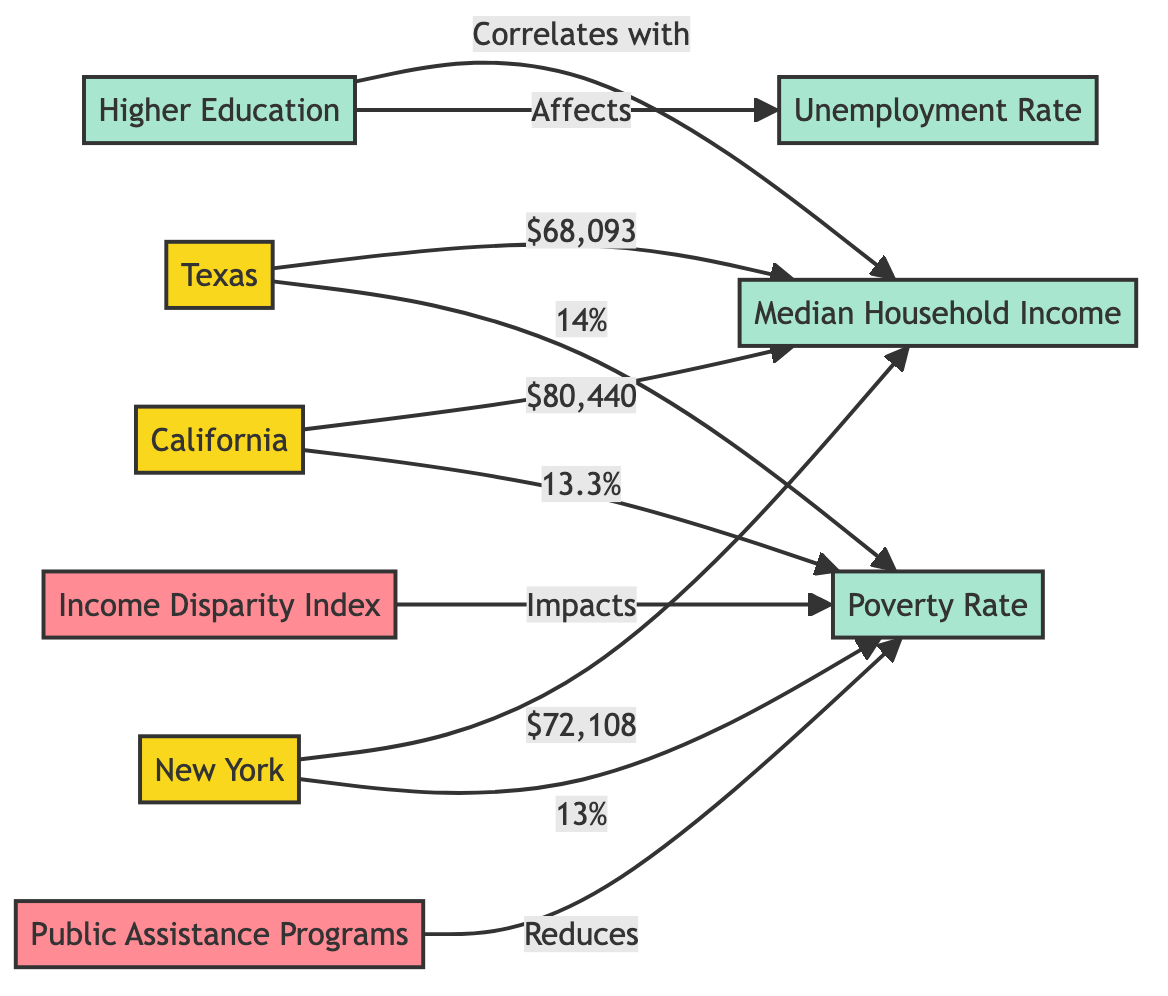What is the median household income for California? The diagram states that California has a median household income of $80,440, which can be directly read from the relevant node connected to California.
Answer: $80,440 What is the unemployment rate related to higher education in the diagram? The flowchart indicates that higher education affects the unemployment rate, but does not specify a numerical value for the unemployment rate. It does not explicitly define the unemployment rate based on higher education data in this diagram.
Answer: Not provided Which state has the highest median household income? By comparing the values for median household income from the nodes for Texas, California, and New York, it is evident that California has the highest median household income at $80,440.
Answer: California What is the poverty rate for Texas? From the diagram, it is shown that Texas has a poverty rate of 14%, which can be extracted directly from the node corresponding to Texas.
Answer: 14% How do public assistance programs impact the poverty rate? According to the diagram, public assistance programs reduce the poverty rate, indicating a relationship of effect without providing a specific numerical change in the poverty rate.
Answer: Reduces Which state has a poverty rate lower than 14%? The diagram reveals that California's poverty rate is 13.3% and New York's poverty rate is 13%, both of which are lower than Texas's rate of 14%.
Answer: California, New York The income disparity index impacts which socioeconomic factor? The diagram illustrates that the income disparity index impacts the poverty rate, showing a direct effect of the disparity index on poverty.
Answer: Poverty Rate What is the relationship between higher education and median household income? The flowchart indicates a correlation between higher education and median household income, as it illustrates that higher education correlates with increased median household income.
Answer: Correlates with Which state has a poverty rate of 13%? By examining the diagram, it can be determined that New York has a poverty rate of 13%, as explicitly stated in the node associated with New York.
Answer: New York 